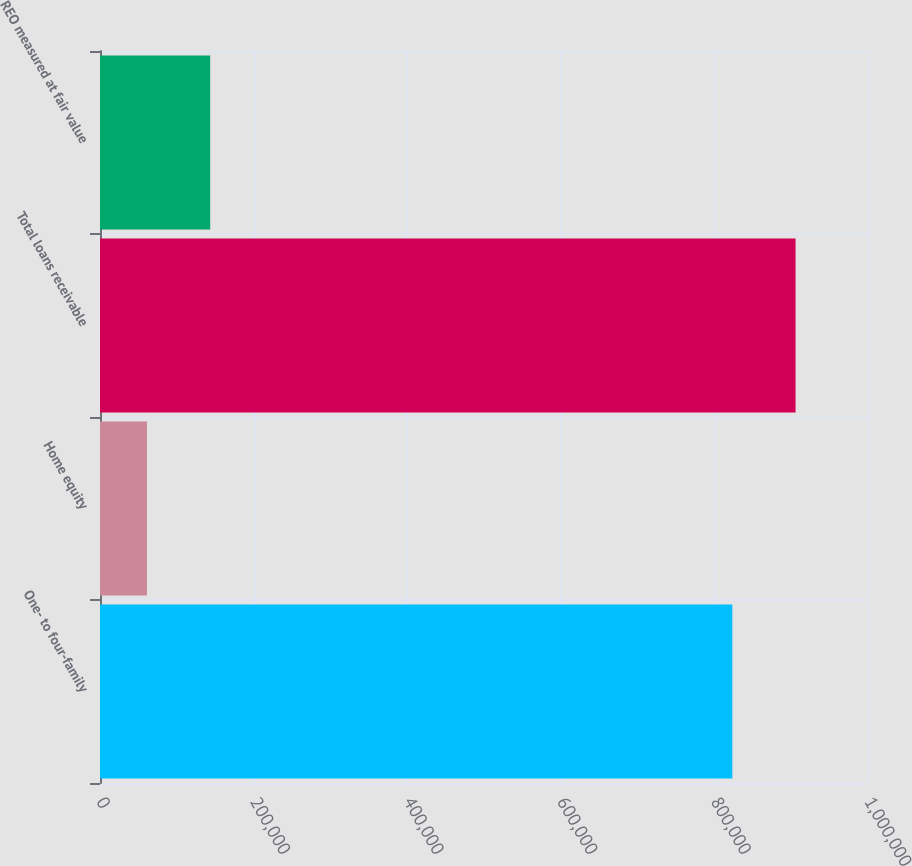Convert chart. <chart><loc_0><loc_0><loc_500><loc_500><bar_chart><fcel>One- to four-family<fcel>Home equity<fcel>Total loans receivable<fcel>REO measured at fair value<nl><fcel>823338<fcel>61163<fcel>905672<fcel>143497<nl></chart> 